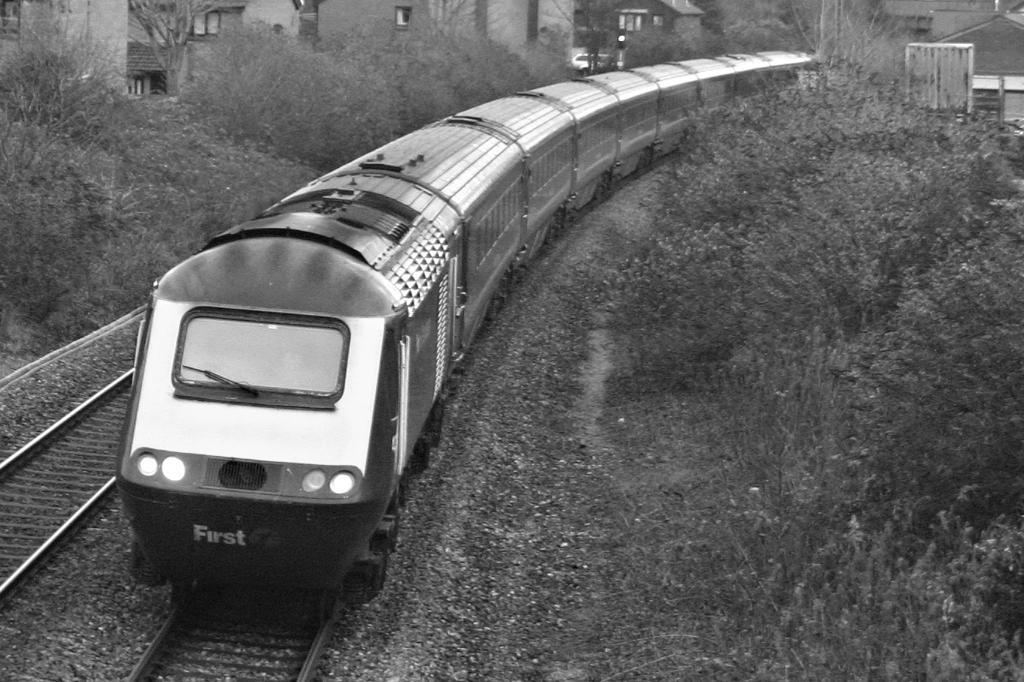What is the color scheme of the image? The image is black and white. What can be seen on the track in the image? There is a train on the track. What type of natural elements are present near the train? There are plants and trees near the train. What type of man-made structures are visible in the image? There are buildings in the vicinity of the train. What else can be seen in the distance in the image? A vehicle is visible in the distance. What type of fold can be seen in the baby's clothing in the image? There is no baby or clothing present in the image; it features a train on a track with surrounding elements. 